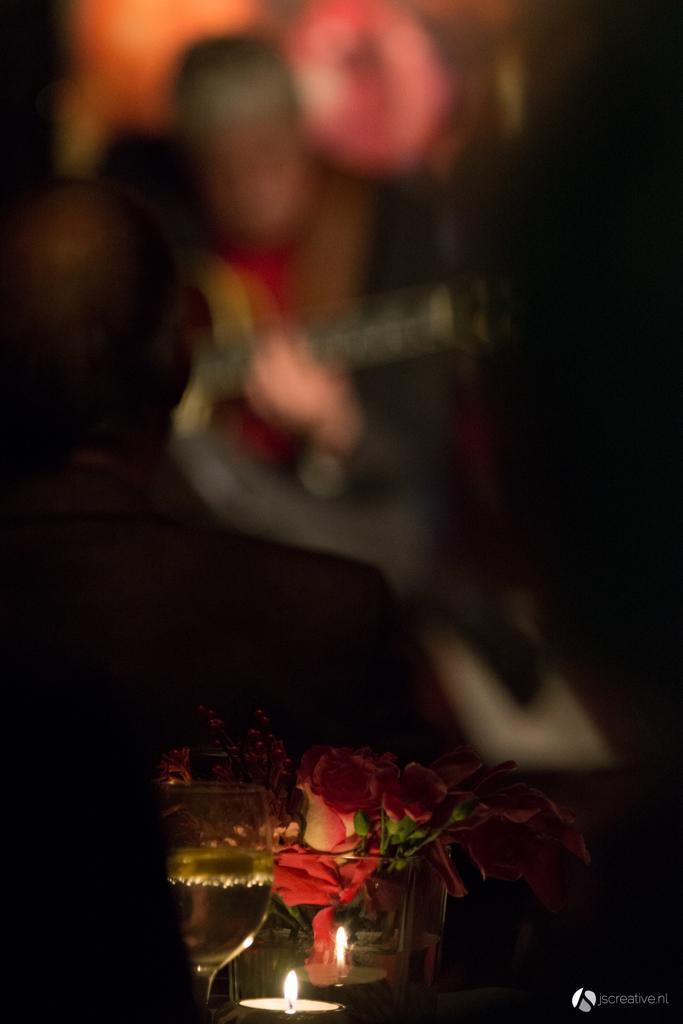Could you give a brief overview of what you see in this image? This is an image clicked in the dark. At the bottom of the image I can see two tealight candles which are placed on a table and there are some rose flowers and also I can see a wine glass. The background is blurred. 